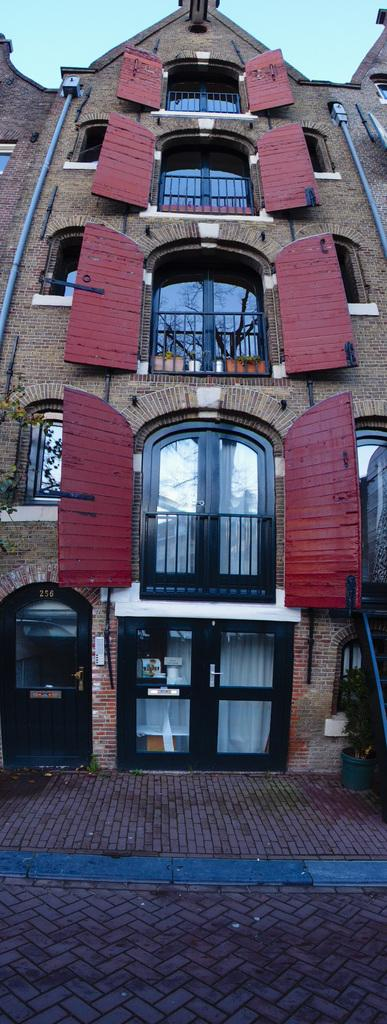What type of surface is visible at the bottom of the image? There is a floor in the image. What type of structure is present in the image? There is a building in the image. What are the openings in the building used for? There are doors in the image, which are used for entering and exiting the building. What are the vertical supports in the image used for? There are poles in the image, which are likely used for structural support or signage. What are the transparent openings in the building used for? There are windows in the image, which allow light to enter the building and provide a view of the outside. What is visible at the top of the image? The sky is visible at the top of the image. What type of cheese is being used to flavor the underwear in the image? There is no cheese or underwear present in the image; it features a building with doors, poles, windows, and a visible sky. 